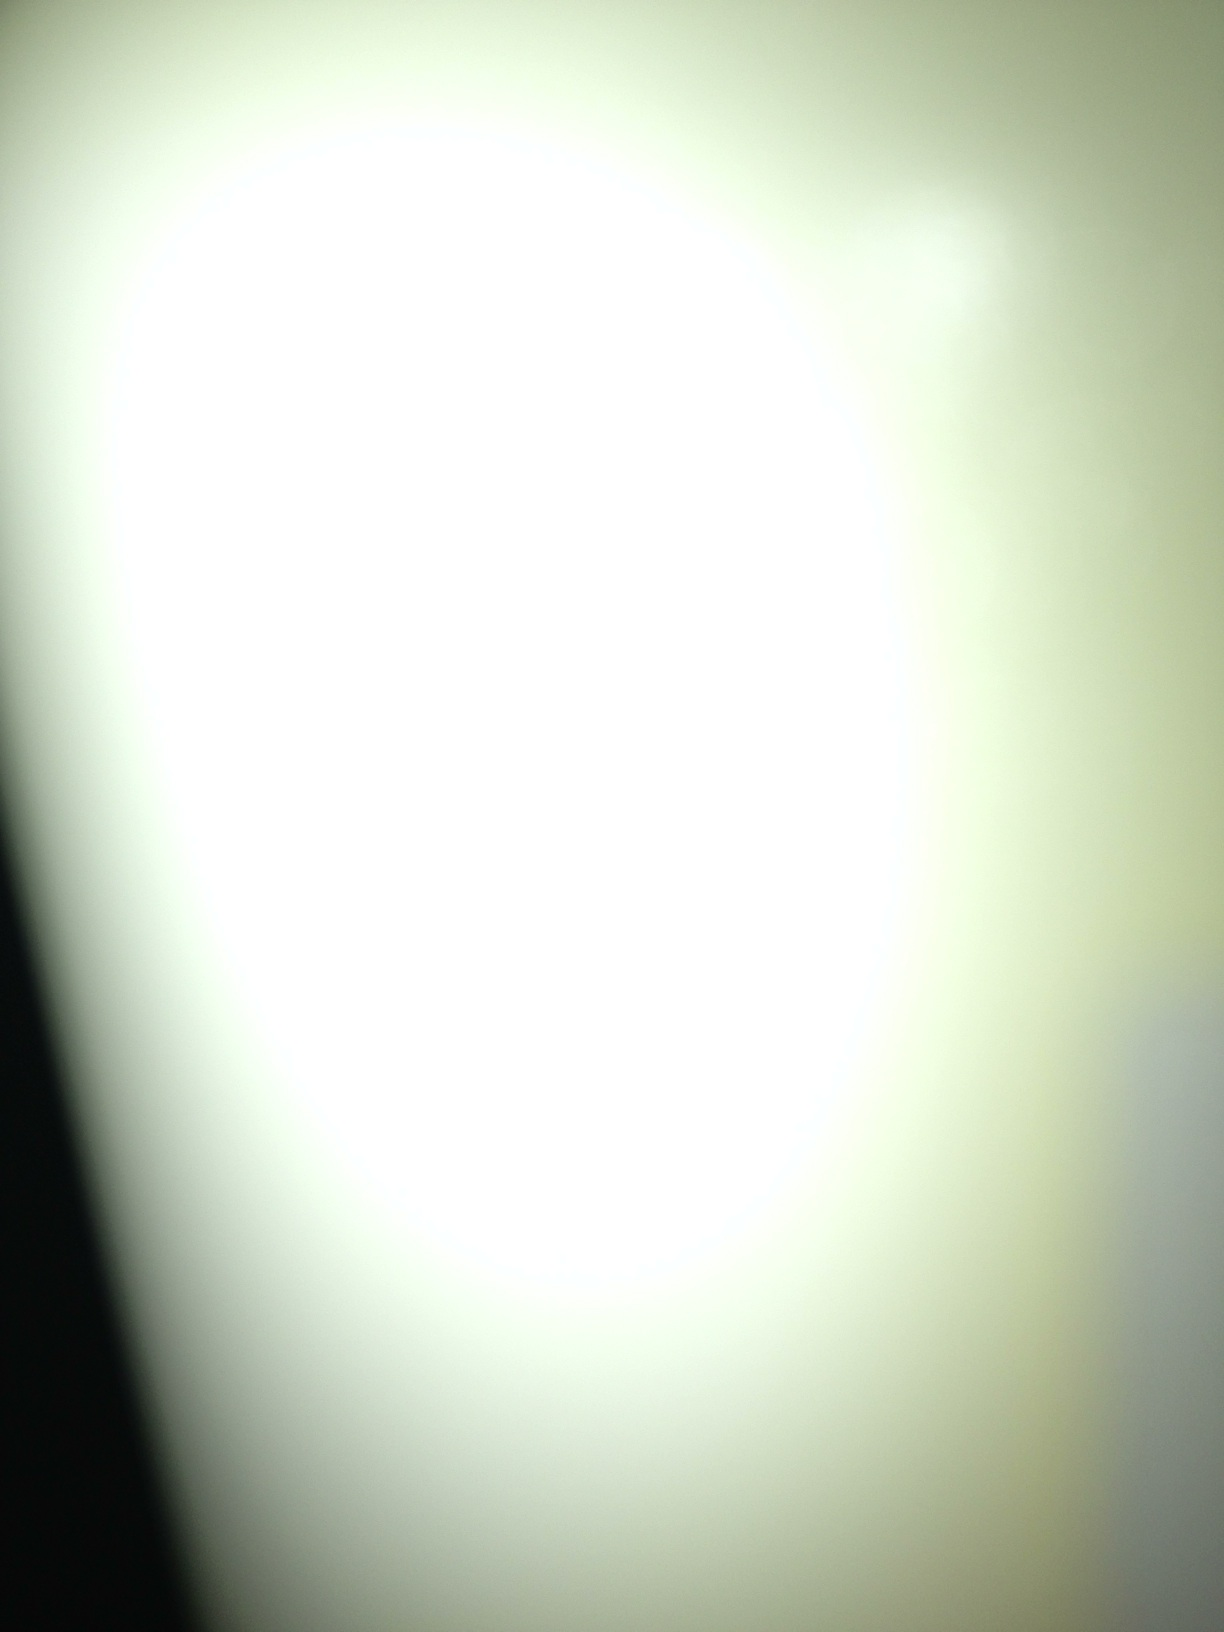What is this? The image appears to be an abstract or out-of-focus picture with a bright, white central area surrounded by a gradient of light to dark shades. It might be a close-up of a light source, such as a lamp or a flashlight, taken with an unfocused camera. 